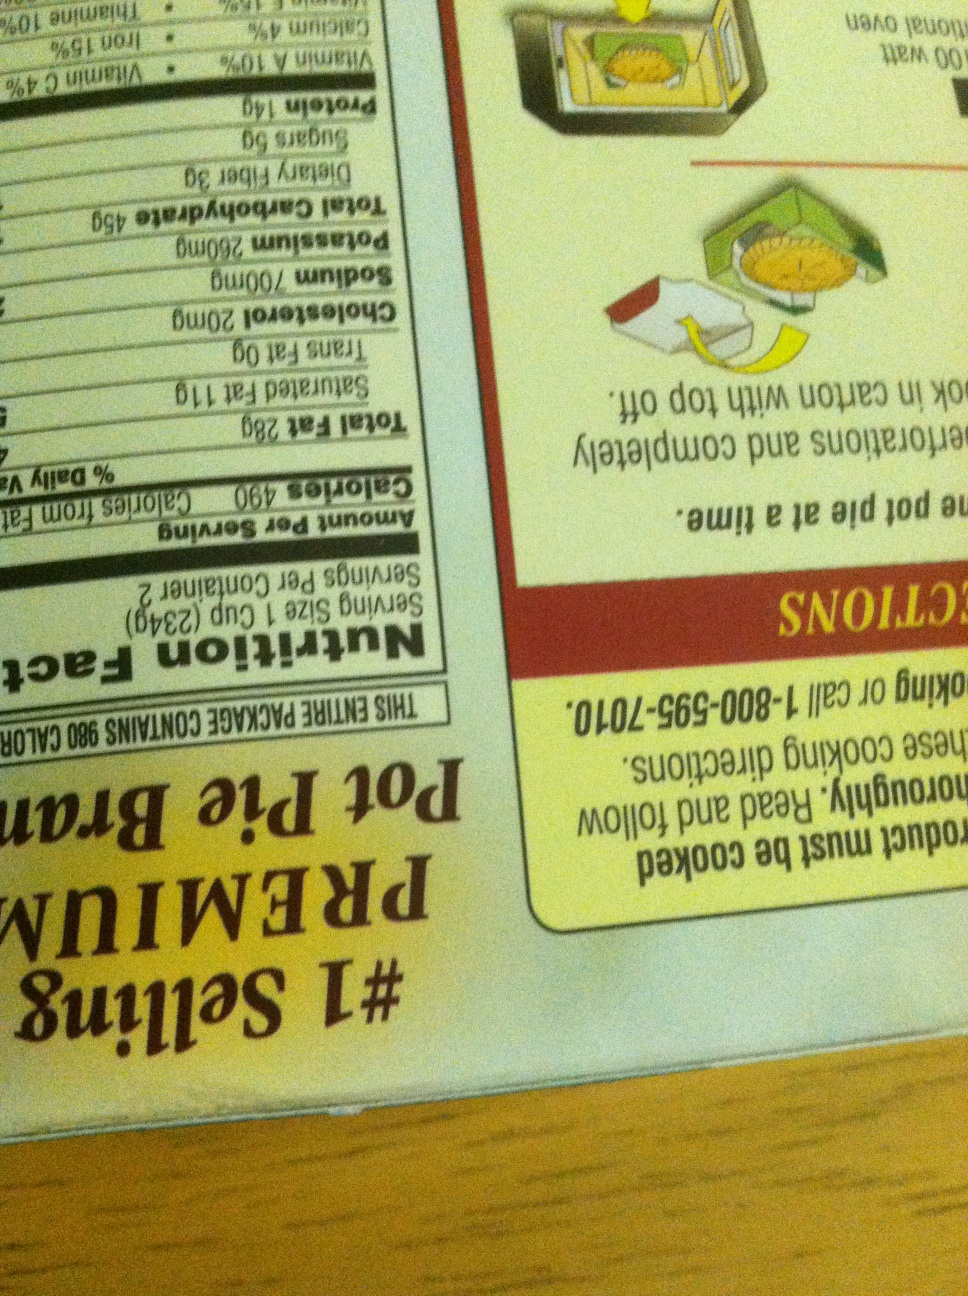Imagine the pot pie box being a character in a mystery novel. What's its role? In a thrilling mystery novel, the pot pie box takes on the role of an unsuspecting clue. Found at a crucial crime scene, its nutritional facts and barcodes lead detectives on a chase across various stores and suppliers. Eventually, these small pieces of evidence tie together to uncover a larger conspiracy involving tampered foods and a mysterious organization. The pot pie box, seemingly ordinary, holds hidden messages and clues, guiding the protagonist step-by-step to unravel the mystery. 